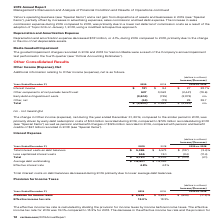According to Verizon Communications's financial document, What was the effective income tax rate for the period 2019? According to the financial document, 13.0%. The relevant text states: "Effective income tax rate 13.0% 18.3%..." Also, What was the effective income tax rate for the period 2018? According to the financial document, 18.3%. The relevant text states: "Effective income tax rate 13.0% 18.3%..." Also, What led to non-recurring deferred tax benefit of approximately $2.1 billion? Based on the financial document, the answer is an internal reorganization of legal entities within the historical Wireless business. Also, can you calculate: What is the change in Provision for income taxes from 2018 to 2019? Based on the calculation: 2,945-3,584, the result is -639 (in millions). This is based on the information: "Provision for income taxes $ 2,945 $ 3,584 $ (639) (17.8)% Provision for income taxes $ 2,945 $ 3,584 $ (639) (17.8)%..." The key data points involved are: 2,945, 3,584. Also, can you calculate: What is the change in Effective income tax rate from 2018 to 2019? Based on the calculation: 13.0-18.3, the result is -5.3 (percentage). This is based on the information: "Effective income tax rate 13.0% 18.3% Effective income tax rate 13.0% 18.3%..." The key data points involved are: 13.0, 18.3. Also, can you calculate: What is the average Effective income tax rate for 2018 and 2019? To answer this question, I need to perform calculations using the financial data. The calculation is: (13.0+18.3) / 2, which equals 15.65 (percentage). This is based on the information: "Effective income tax rate 13.0% 18.3% Effective income tax rate 13.0% 18.3%..." The key data points involved are: 13.0, 18.3. 